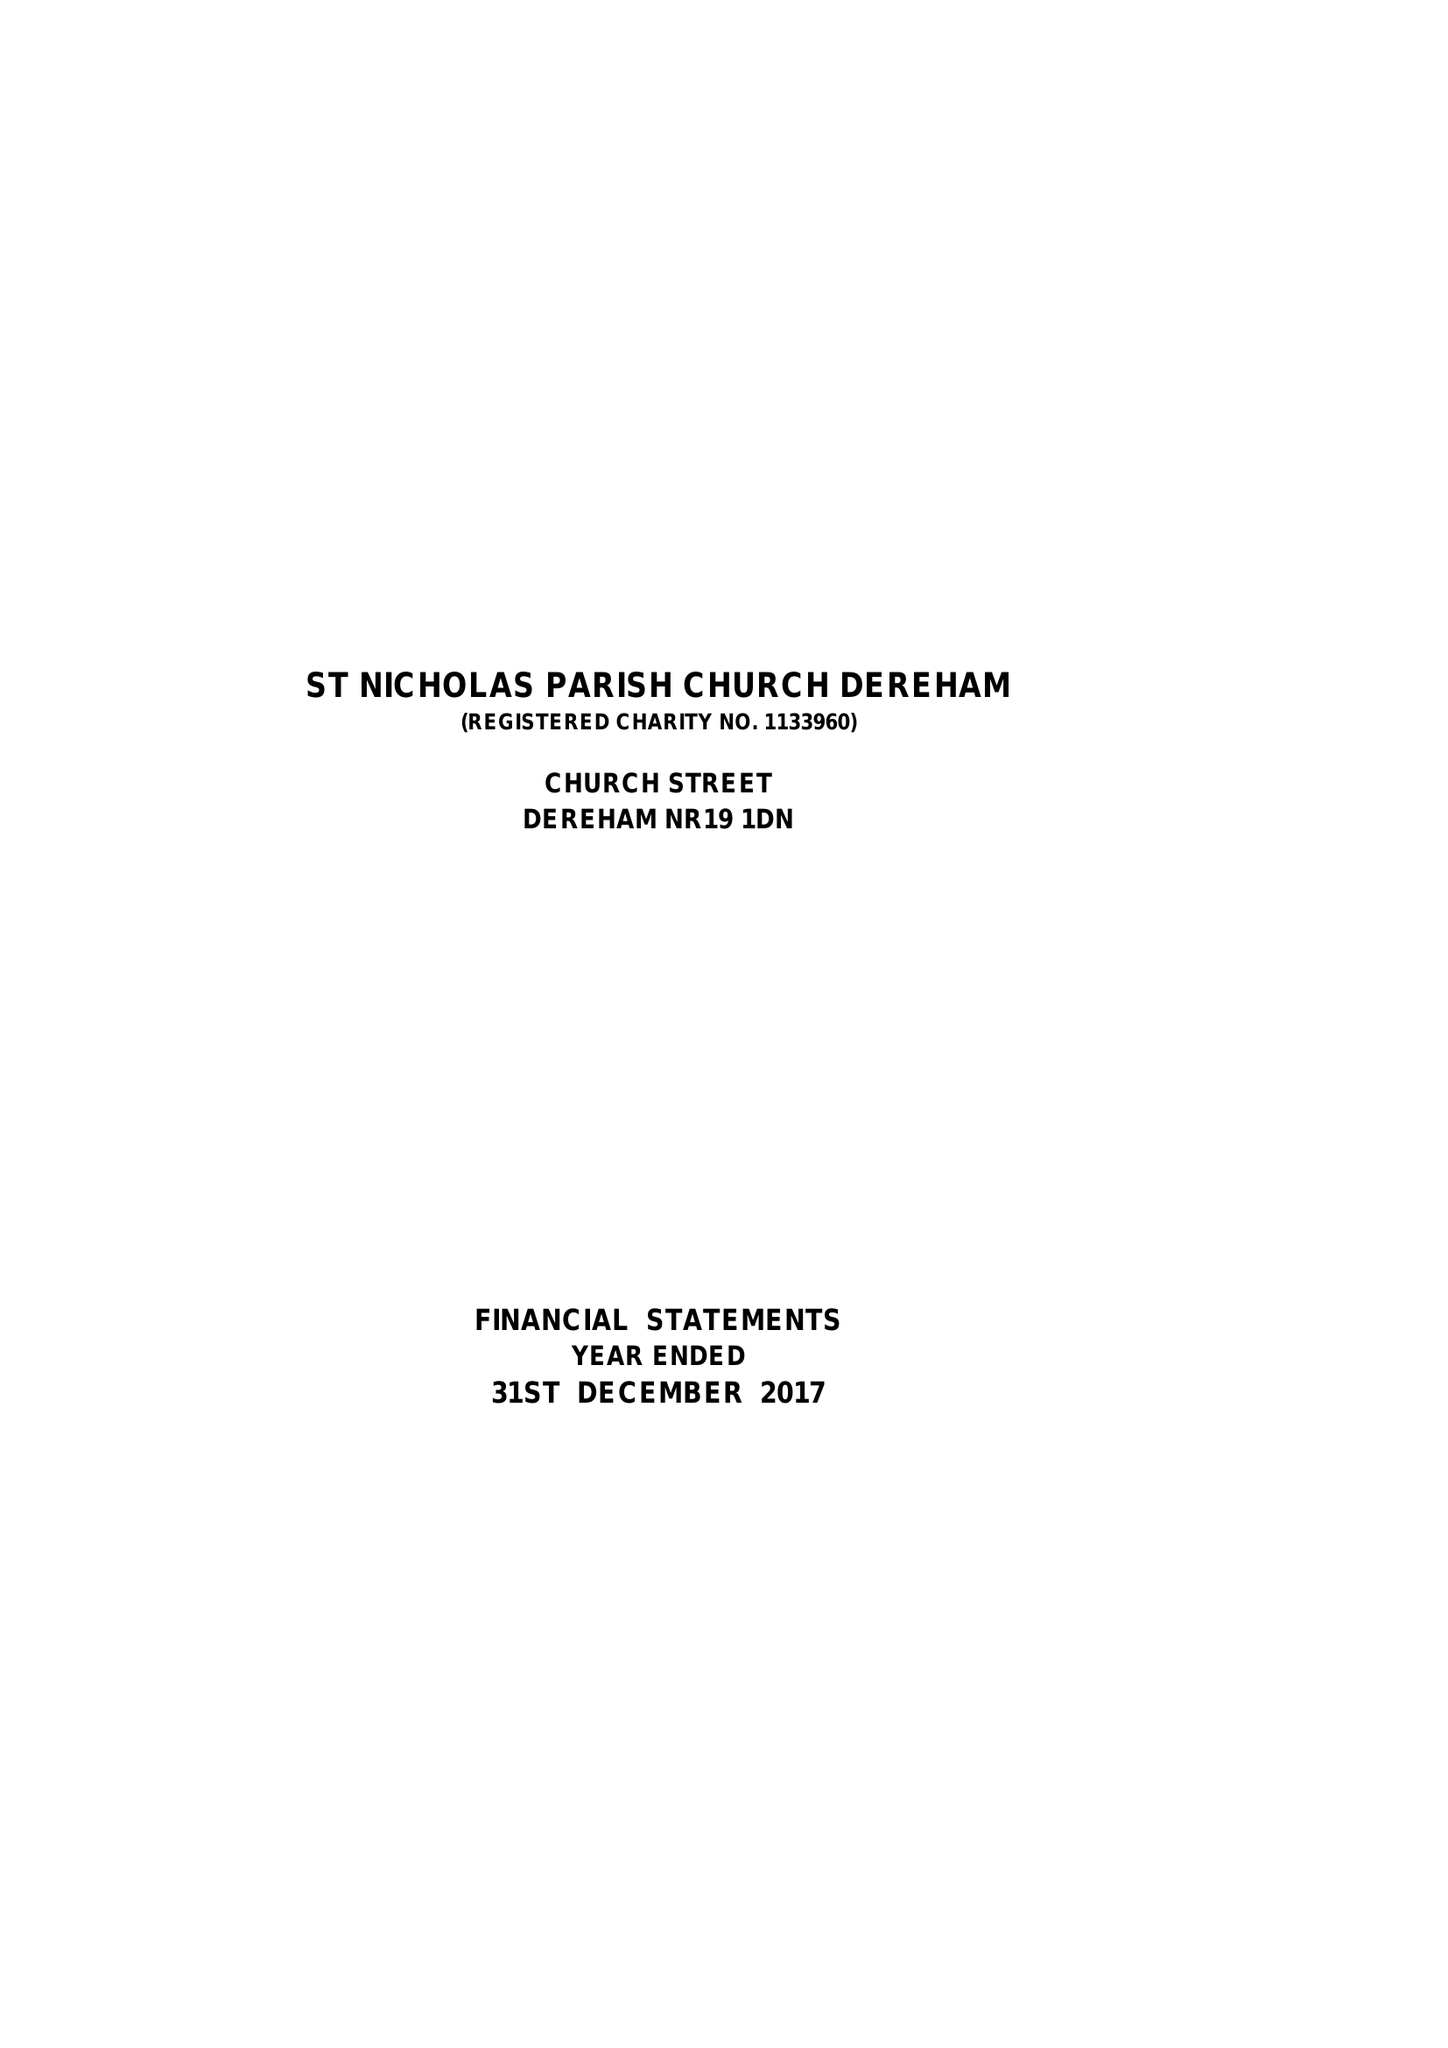What is the value for the income_annually_in_british_pounds?
Answer the question using a single word or phrase. 111139.00 